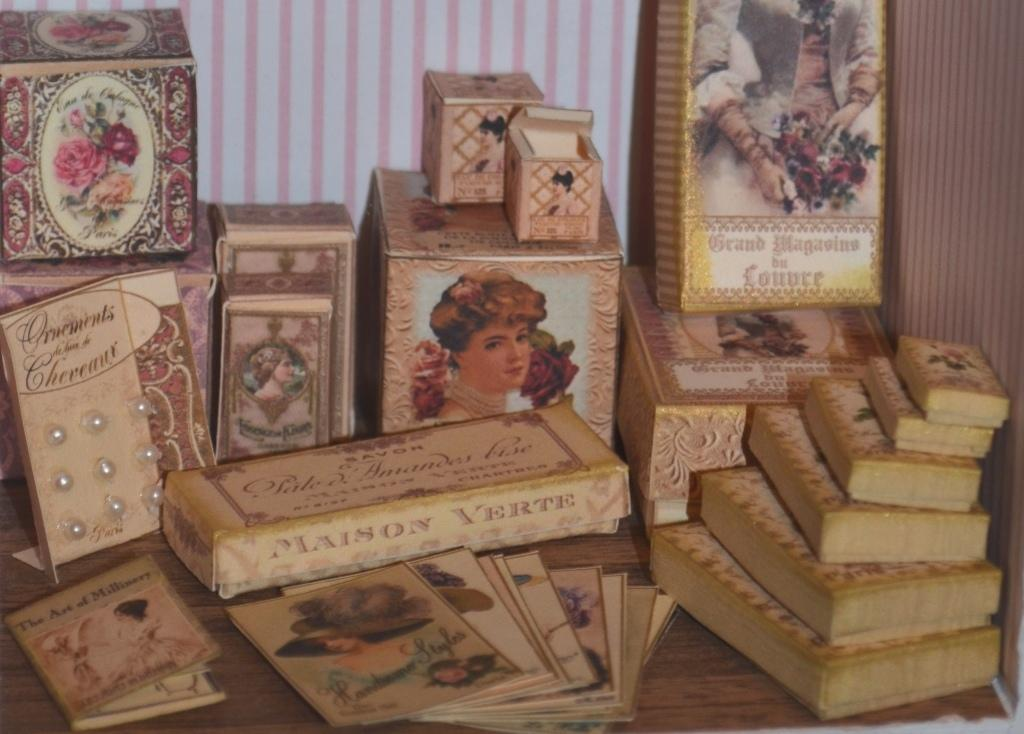<image>
Render a clear and concise summary of the photo. The Art of Milinery is well sought after piece for antique shows. 